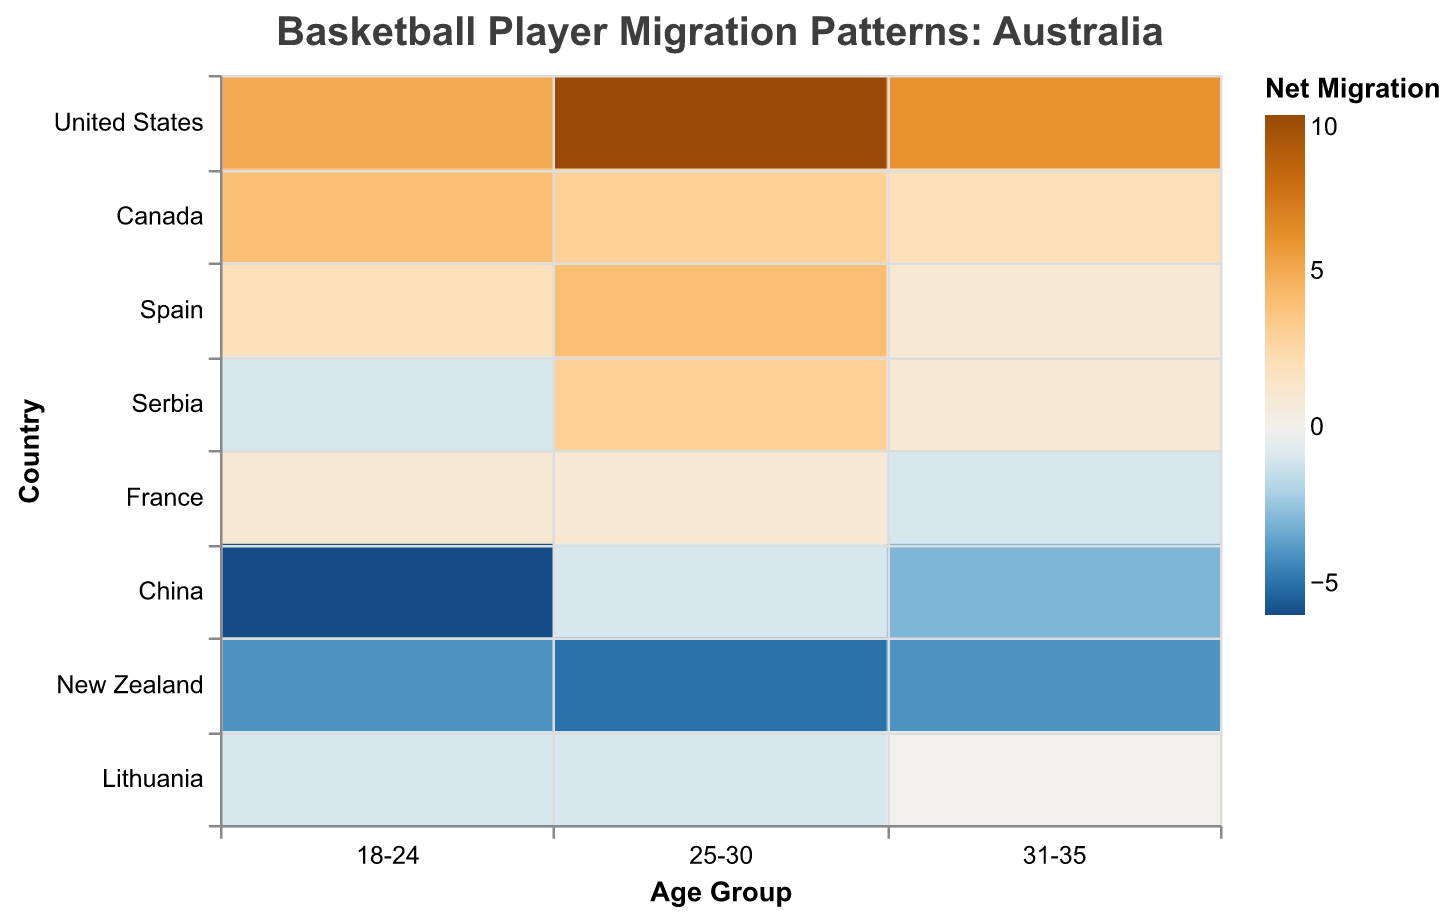What's the title of the heatmap? The title is located at the top center of the heatmap in a larger font size than the other text elements. It summarizes the purpose of the heatmap.
Answer: Basketball Player Migration Patterns: Australia Which country has the highest net migration to Australia for the 25-30 age group? To find this, look at the color intensity in the 25-30 age group column and identify the country row with the highest positive value, which suggests the highest net migration to Australia. In this case, United States has the highest net migration.
Answer: United States What is the net migration for players aged 18-24 from China to Australia? Locate the China row and then find the color in the 18-24 age group column. The net migration value is indicated by the color intensity in the heatmap legend. The net migration value is the difference between players moving to Australia (3) and players moving from Australia (9), which is -6.
Answer: -6 Compare the net migration trends between France and New Zealand for players aged 18-24. Look at the color intensities in the France and New Zealand rows under the 18-24 column. France shows a dark orange shade (positive net migration = 7-6) indicating a small net positive migration, while New Zealand shows a darker blue shade (negative net migration = 6-10), indicating a net negative migration.
Answer: New Zealand has a higher negative net migration compared to France for the 18-24 age group How does the net migration pattern for players aged 31-35 from Canada compare to Lithuania? Identify the color shades in the 31-35 age group for both Canada and Lithuania. Canada has a color close to light orange indicating a small positive net migration (difference = 3-1), while Lithuania has a neutral shade representing zero net migration (difference = 1-1).
Answer: Canada has a higher positive net migration than Lithuania in the 31-35 age group What age group sees the largest migration from the United States to Australia? Analyze the shades of color in the United States row. The darkest orange represents the largest positive migration, which corresponds to the 25-30 age group.
Answer: 25-30 Which country has the most balanced migration with Australia for the 31-35 age group? Look for the country with the closest color to neutral (white-ish gray) in the age group 31-35 column. Both Spain and Lithuania have neutral shades, meaning their net migration values are balanced (2-1 and 1-1 respectively). Spain and Lithuania are tied for this metric but Lithuania is perfectly balanced.
Answer: Lithuania What's the total number of players moving to Australia from Spain across all age groups? Sum the player counts for each age group (18-24, 25-30, 31-35) from Spain moving to Australia: 5 + 6 + 2.
Answer: 13 Which country has a higher net migration to Australia for the 25-30 age group: Serbia or Canada? Examine the color shades in the 25-30 column for Serbia and Canada. Serbia has a light orange shade (net positive migration: 6-3) and Canada has a darker orange shade (net positive migration: 7-4). Compare the results to find that Serbia's net migration (3) is less than Canada's (3).
Answer: Canada What can be inferred about the net migration trend for players aged 18-24 from New Zealand? The color for New Zealand in the 18-24 age group is dark blue, indicating a high negative net migration. By checking the specific numbers, the difference is 6 (to Australia) - 10 (from Australia) = -4. This implies many young players are moving from Australia to New Zealand.
Answer: High negative net migration 